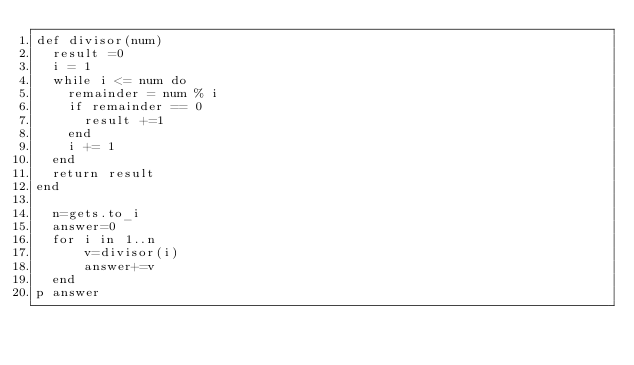Convert code to text. <code><loc_0><loc_0><loc_500><loc_500><_Ruby_>def divisor(num)
  result =0
  i = 1
  while i <= num do
    remainder = num % i
    if remainder == 0
      result +=1
    end
    i += 1
  end
  return result
end

  n=gets.to_i
  answer=0
  for i in 1..n
      v=divisor(i)
      answer+=v
  end
p answer</code> 